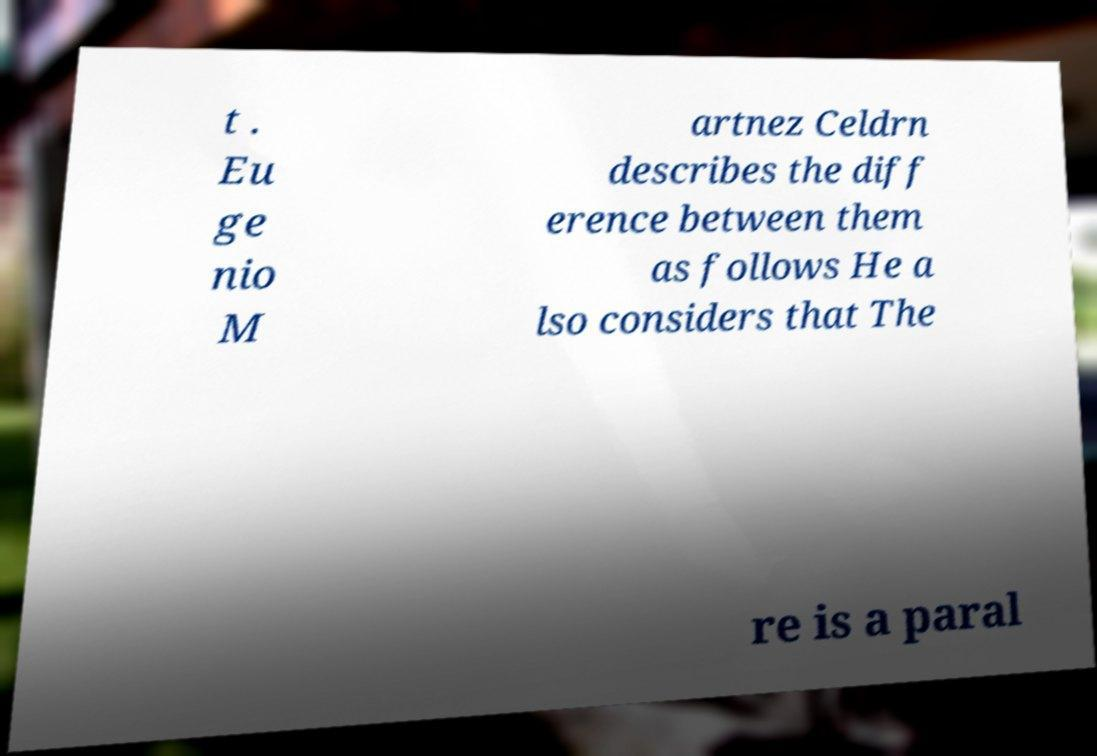Could you assist in decoding the text presented in this image and type it out clearly? t . Eu ge nio M artnez Celdrn describes the diff erence between them as follows He a lso considers that The re is a paral 